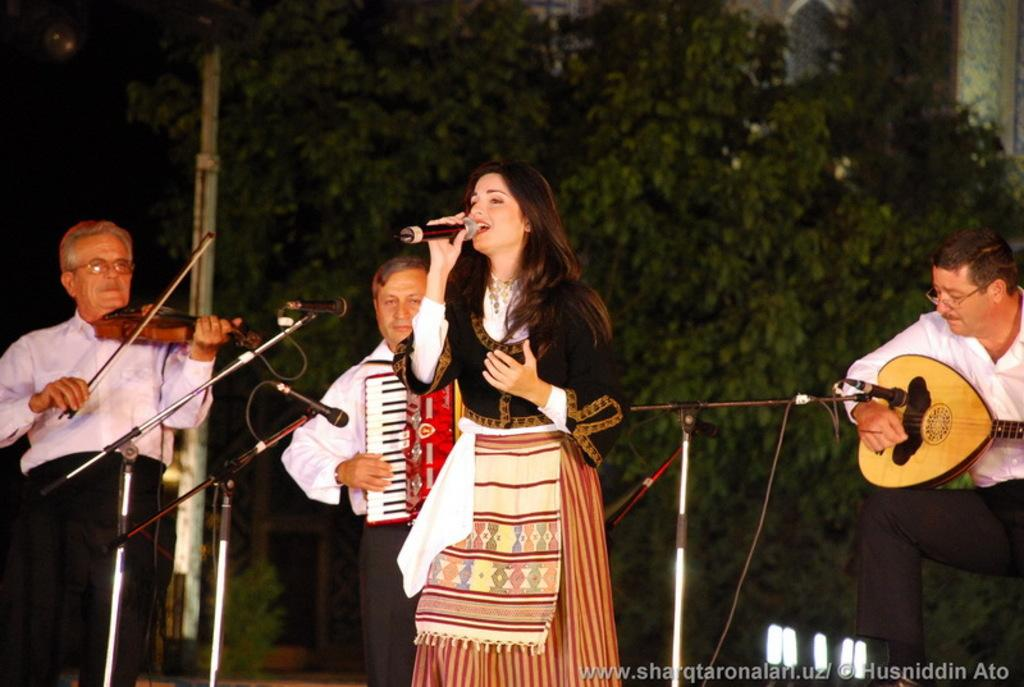What is the main subject of the image? The main subject of the image is a woman. What is the woman wearing in the image? The woman is wearing a gown in the image. What is the woman doing in the image? The woman is singing on a mic in the image. How many men are present in the image? There are three men present in the image. What are the men doing in the image? The men are playing musical instruments in the image. Where are the men positioned in relation to the mic? The men are in front of a mic in the image. What can be seen in the background of the image? There are trees and lights visible in the background of the image. How many waves can be seen crashing on the shore in the image? There are no waves visible in the image; it features a woman singing and men playing musical instruments. What type of bit is being used by the woman to control the mic in the image? The image does not show the woman using any bit to control the mic; she is simply singing into it. 